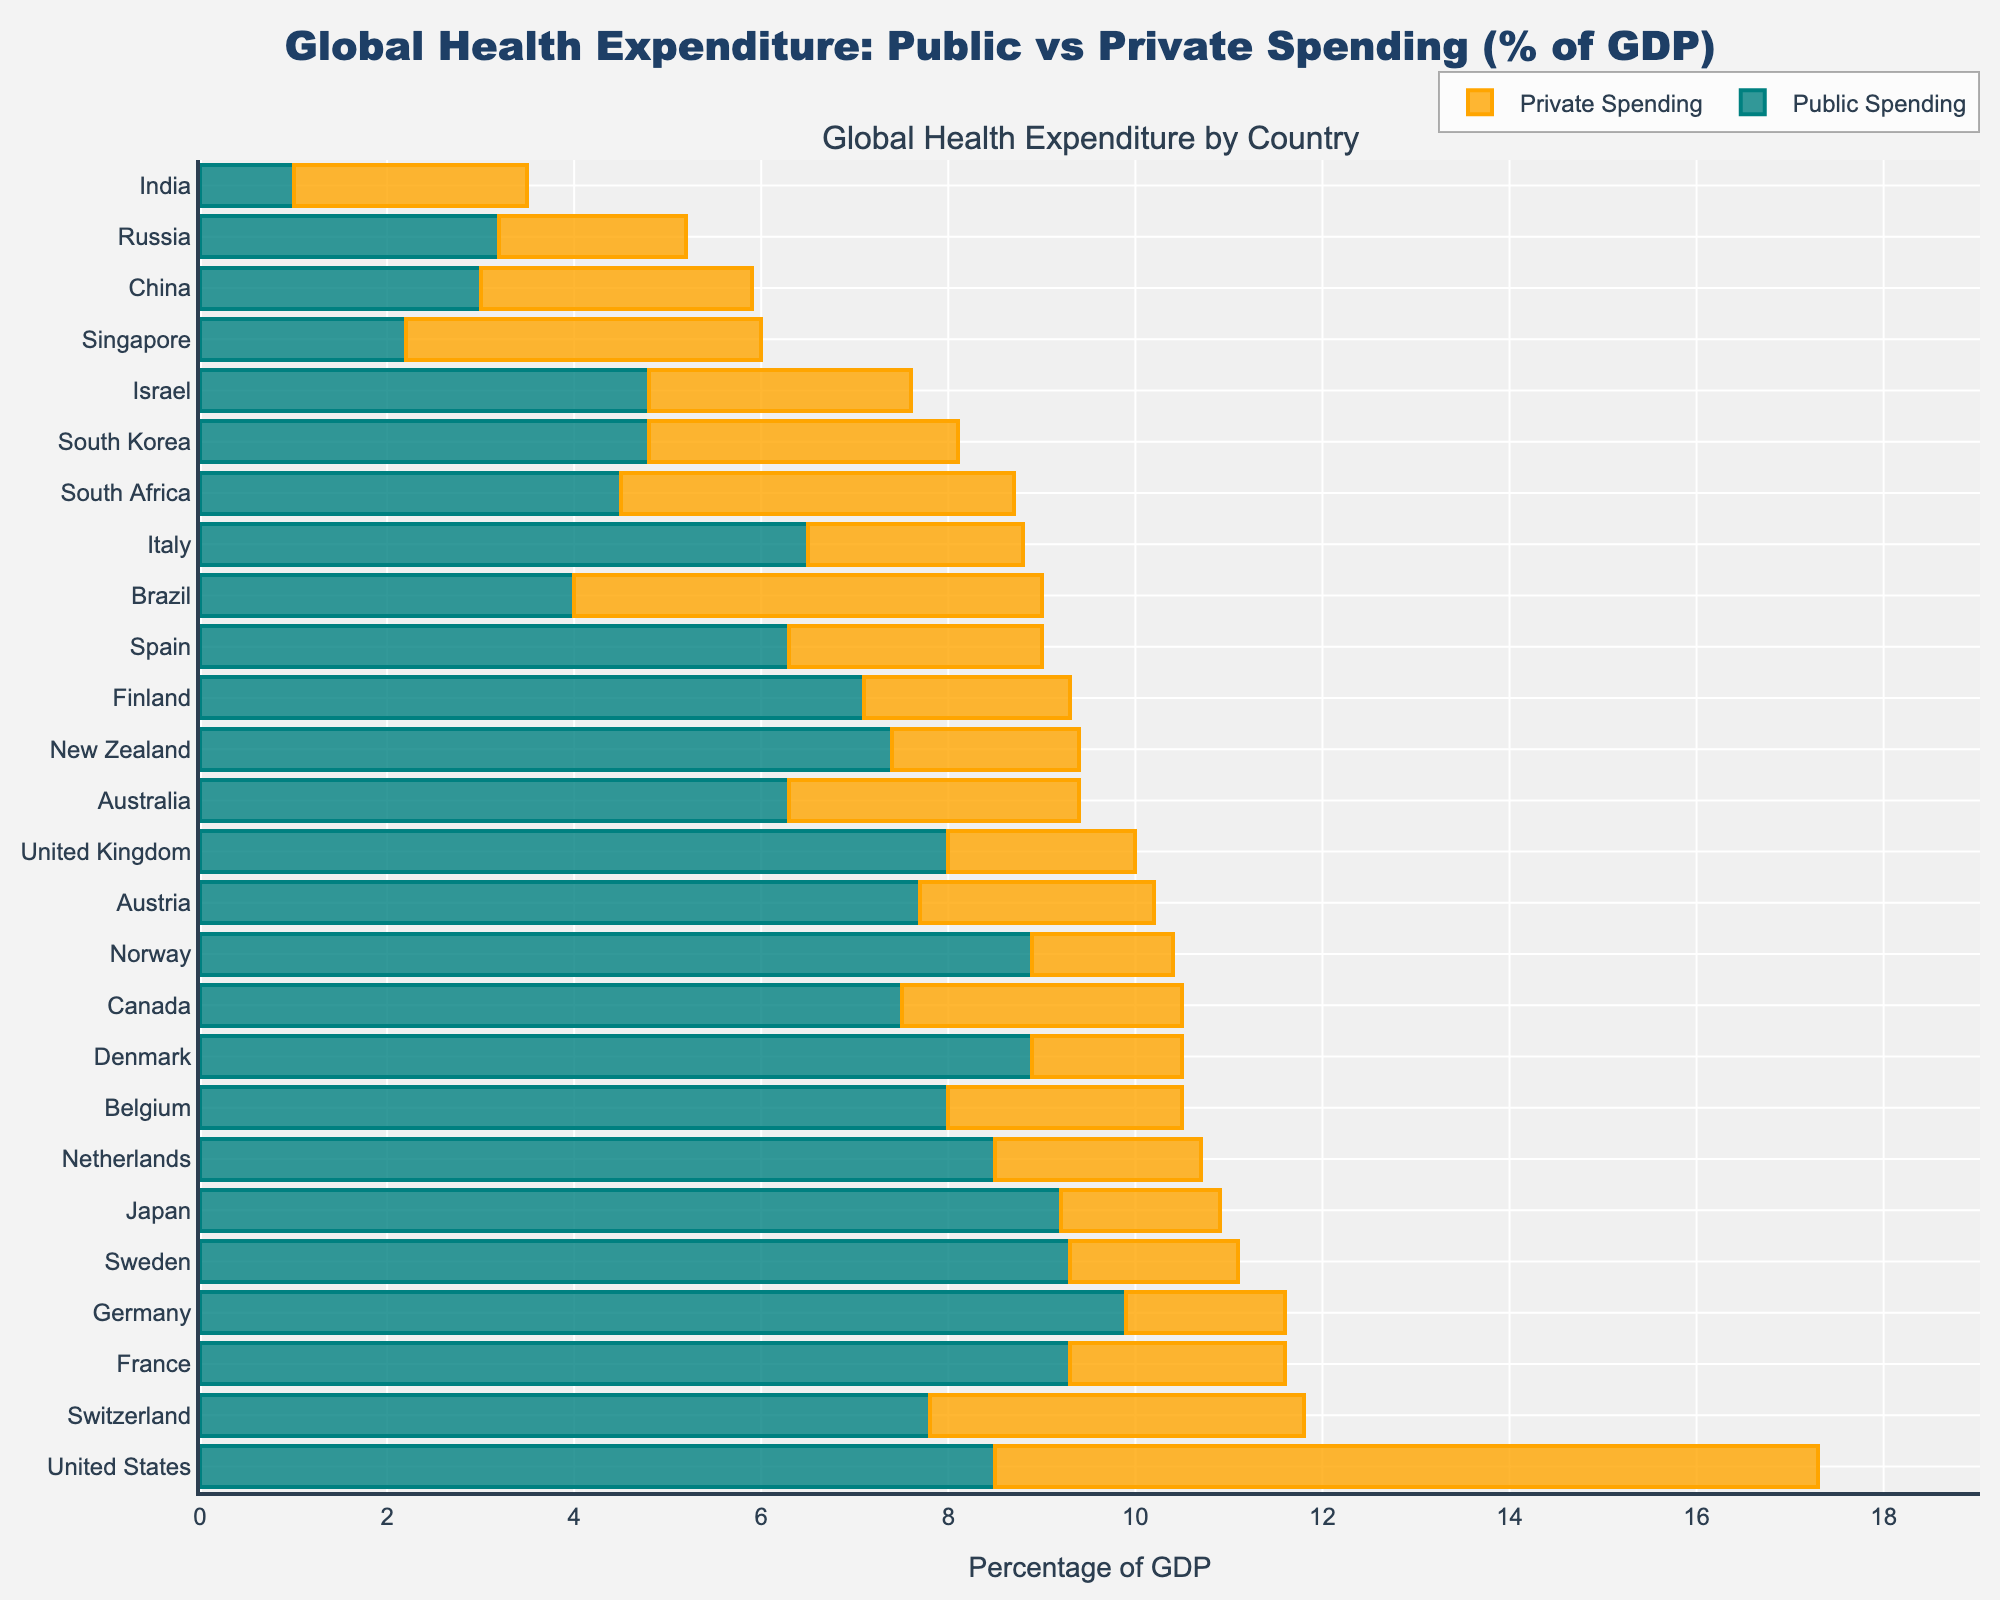Which country has the highest combined public and private health expenditure? To find the country with the highest combined expenditure, sum up the public and private spending for each country and identify the largest value. The country with the highest total is the United States (8.5 + 8.8 = 17.3)
Answer: United States Which country has the lowest public health expenditure as a percentage of GDP? Locate the bar representing public spending and identify the smallest value among them. Singapore has the lowest public health expenditure at 2.2% of GDP.
Answer: Singapore What is the difference between public and private spending in Switzerland? Subtract private spending from public spending in Switzerland: 7.8 - 4.0 = 3.8%.
Answer: 3.8% How does Canada's private health expenditure compare to that of Australia? Compare the length of the bars representing private spending in Canada and Australia. Canada's private spending is 3.0%, while Australia's is 3.1%. Australia spends slightly more on private health expenditure than Canada.
Answer: Australia Which countries have a higher private health expenditure than public health expenditure? Identify countries where the bar for private spending is longer than the bar for public spending. The countries are the United States and Singapore.
Answer: United States, Singapore Which country has the largest disparity between public and private spending, and what is the value? Calculate the difference between public and private spending for each country. The largest difference is in the United States, where the disparity is 8.8 - 8.5 = -0.3% (absolute value is 0.3%).
Answer: United States, 0.3% What is the average public health expenditure among European countries listed? Sum the public spending percentages of European countries (Germany, United Kingdom, France, Sweden, Netherlands, Switzerland, Spain, Italy, Norway, Denmark, Belgium, Austria, Finland) and divide by the number of countries. Average = (9.9 + 8.0 + 9.3 + 9.3 + 8.5 + 7.8 + 6.3 + 6.5 + 8.9 + 8.9 + 8.0 + 7.7 + 7.1) / 13 = 8.1%
Answer: 8.1% Which country in Asia has the highest total health expenditure? Review the combined (public + private) spending values for Asian countries (Japan, South Korea, Israel, Singapore, China, India). Japan has the highest total health expenditure at 9.2 + 1.7 = 10.9%.
Answer: Japan What is the combined health expenditure of Brazil, and how does it compare to South Africa? Calculate the sum of public and private expenditures for both Brazil and South Africa and compare them. Brazil: 4.0 + 5.0 = 9.0%, South Africa: 4.5 + 4.2 = 8.7%. Therefore, Brazil spends 0.3% more.
Answer: Brazil, 0.3% more than South Africa 